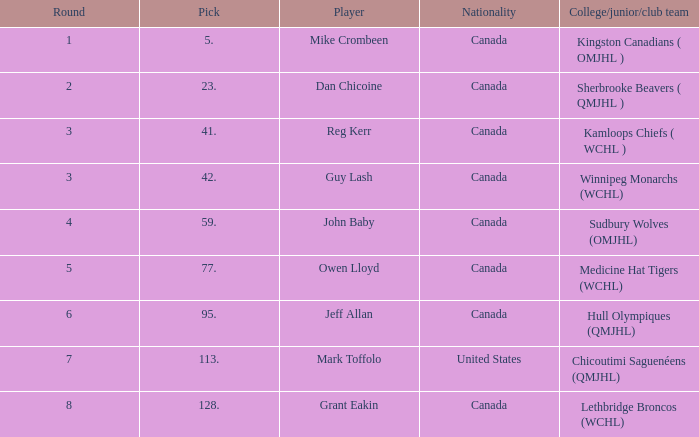Which College/junior/club team has a Round of 2? Sherbrooke Beavers ( QMJHL ). 